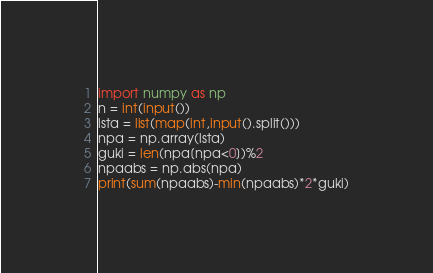Convert code to text. <code><loc_0><loc_0><loc_500><loc_500><_Python_>import numpy as np
n = int(input())
lsta = list(map(int,input().split()))
npa = np.array(lsta)
guki = len(npa[npa<0])%2
npaabs = np.abs(npa)
print(sum(npaabs)-min(npaabs)*2*guki)</code> 